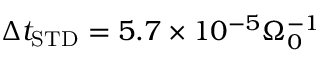<formula> <loc_0><loc_0><loc_500><loc_500>\Delta t _ { S T D } = 5 . 7 \times 1 0 ^ { - 5 } \Omega _ { 0 } ^ { - 1 }</formula> 